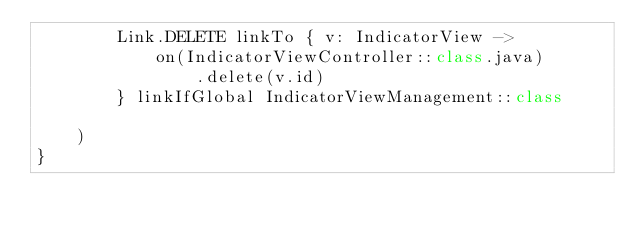Convert code to text. <code><loc_0><loc_0><loc_500><loc_500><_Kotlin_>        Link.DELETE linkTo { v: IndicatorView ->
            on(IndicatorViewController::class.java)
                .delete(v.id)
        } linkIfGlobal IndicatorViewManagement::class

    )
}</code> 